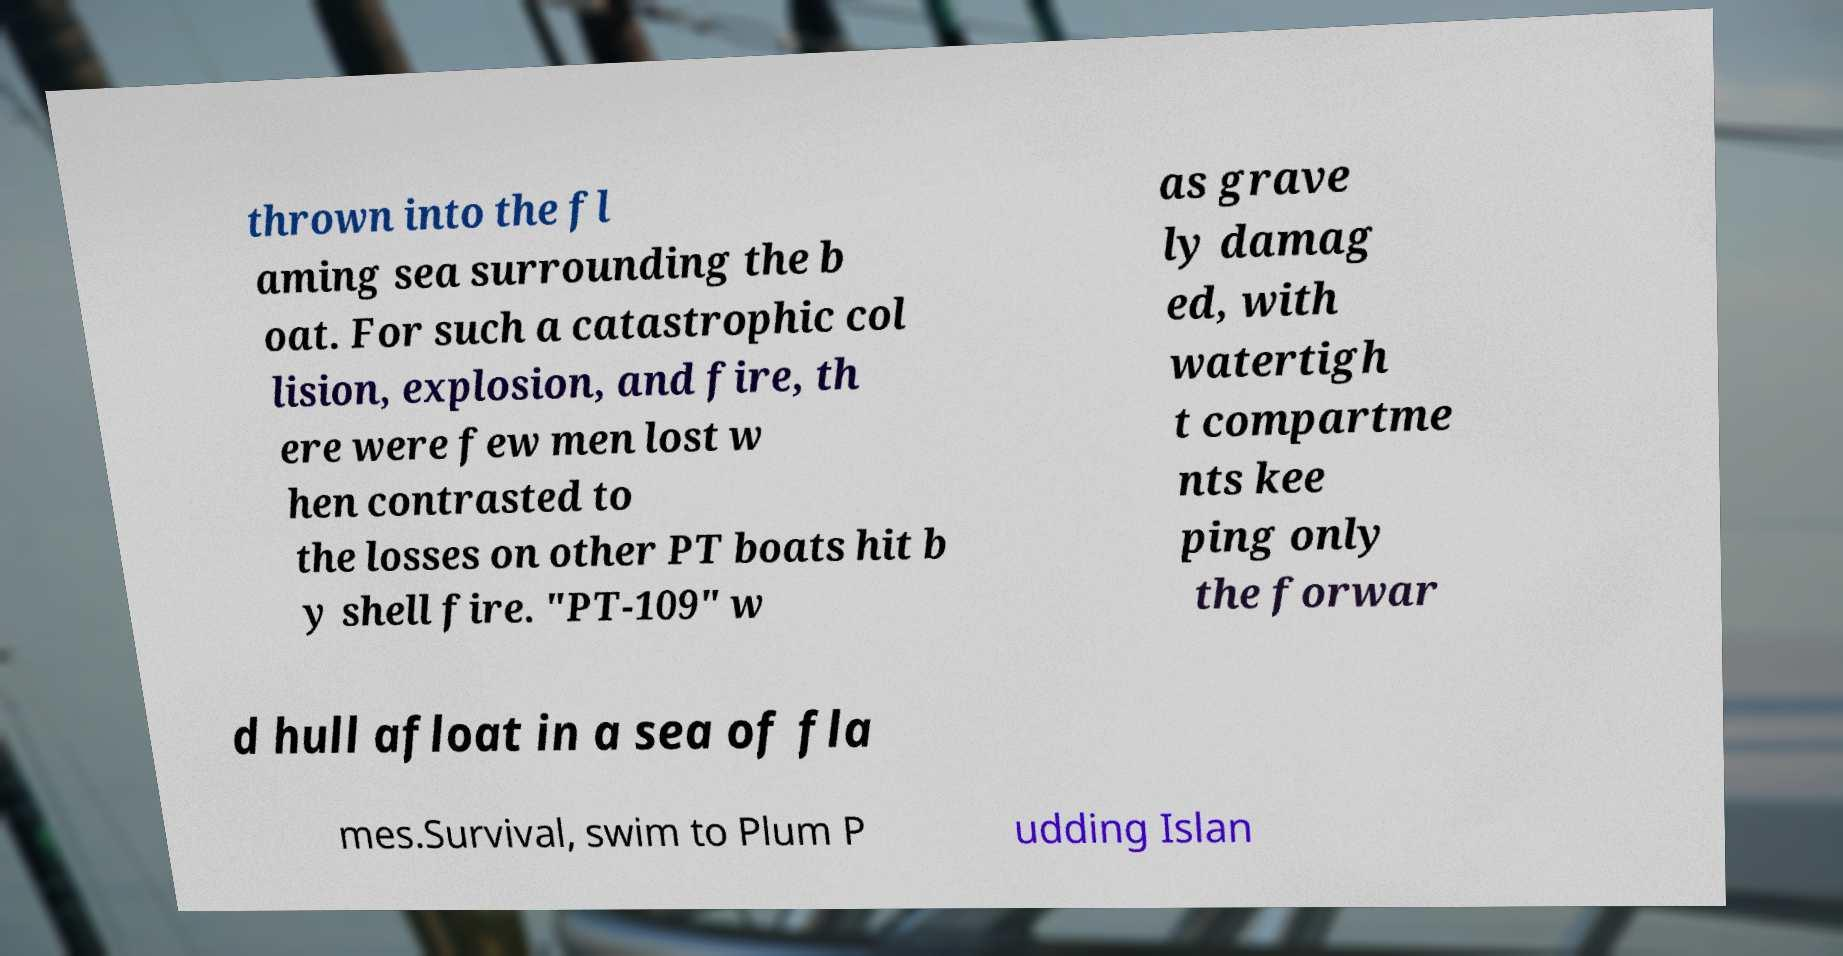Please read and relay the text visible in this image. What does it say? thrown into the fl aming sea surrounding the b oat. For such a catastrophic col lision, explosion, and fire, th ere were few men lost w hen contrasted to the losses on other PT boats hit b y shell fire. "PT-109" w as grave ly damag ed, with watertigh t compartme nts kee ping only the forwar d hull afloat in a sea of fla mes.Survival, swim to Plum P udding Islan 